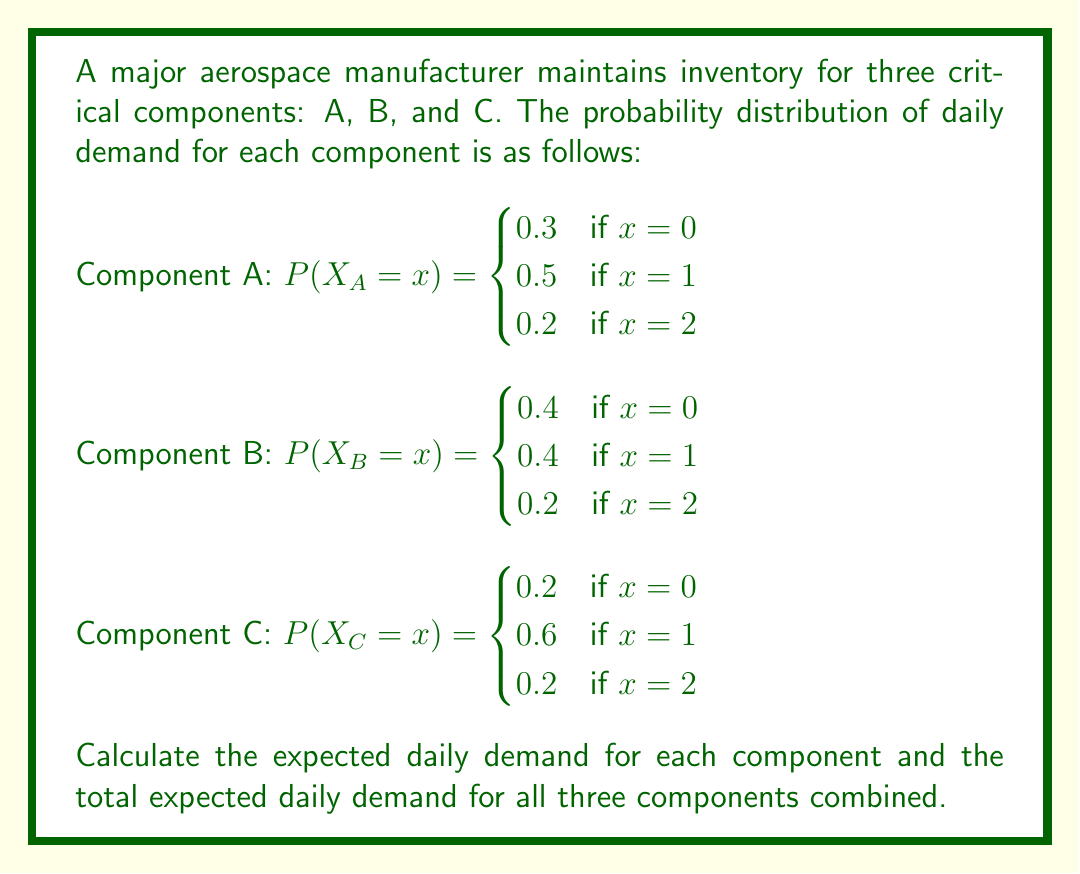Solve this math problem. To solve this problem, we need to calculate the expected value for each component and then sum them up for the total expected daily demand.

1. For Component A:
   $E(X_A) = 0 \cdot P(X_A = 0) + 1 \cdot P(X_A = 1) + 2 \cdot P(X_A = 2)$
   $E(X_A) = 0 \cdot 0.3 + 1 \cdot 0.5 + 2 \cdot 0.2$
   $E(X_A) = 0 + 0.5 + 0.4 = 0.9$

2. For Component B:
   $E(X_B) = 0 \cdot P(X_B = 0) + 1 \cdot P(X_B = 1) + 2 \cdot P(X_B = 2)$
   $E(X_B) = 0 \cdot 0.4 + 1 \cdot 0.4 + 2 \cdot 0.2$
   $E(X_B) = 0 + 0.4 + 0.4 = 0.8$

3. For Component C:
   $E(X_C) = 0 \cdot P(X_C = 0) + 1 \cdot P(X_C = 1) + 2 \cdot P(X_C = 2)$
   $E(X_C) = 0 \cdot 0.2 + 1 \cdot 0.6 + 2 \cdot 0.2$
   $E(X_C) = 0 + 0.6 + 0.4 = 1.0$

4. Total expected daily demand:
   $E(X_{total}) = E(X_A) + E(X_B) + E(X_C)$
   $E(X_{total}) = 0.9 + 0.8 + 1.0 = 2.7$
Answer: Expected daily demand: A: 0.9, B: 0.8, C: 1.0; Total: 2.7 